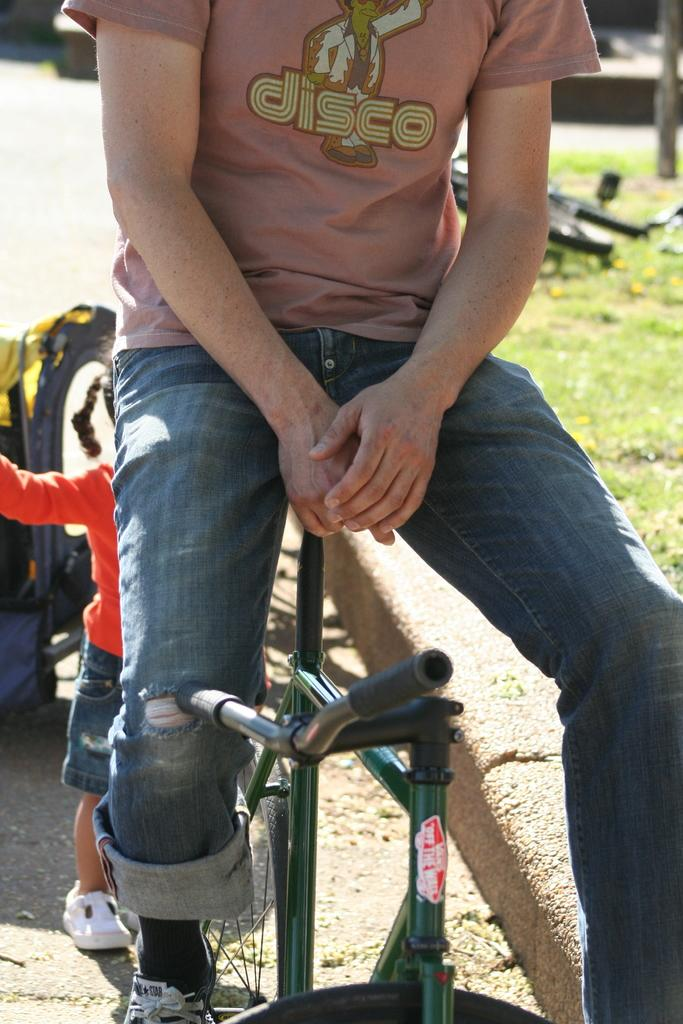What is the person in the image doing? The person is sitting on a bicycle. Where is the bicycle located in the image? The bicycle is on the grass in the distance. Can you describe the person's surroundings? There is a kid behind the person sitting on the bicycle. What type of thread is being used to create the arch in the image? There is no arch present in the image, so there is no thread being used. 